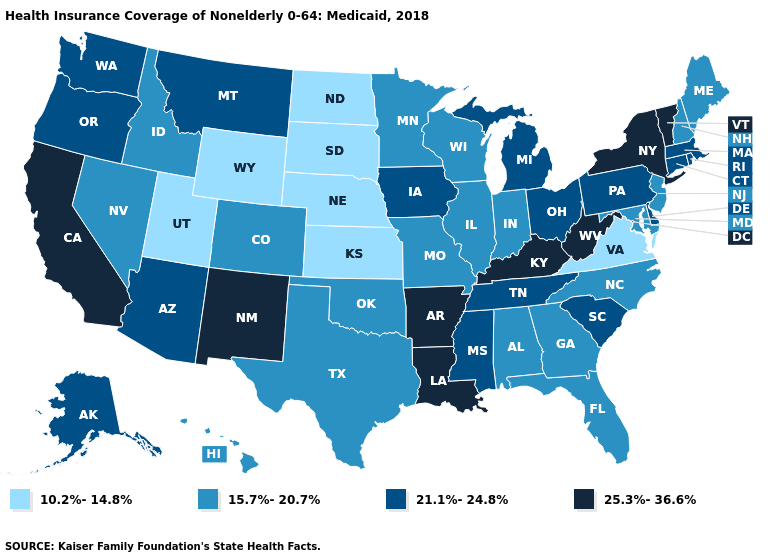Does Minnesota have a higher value than Texas?
Quick response, please. No. How many symbols are there in the legend?
Concise answer only. 4. Among the states that border Washington , which have the highest value?
Quick response, please. Oregon. Does Iowa have a higher value than Oregon?
Write a very short answer. No. What is the value of Alaska?
Answer briefly. 21.1%-24.8%. Which states have the lowest value in the Northeast?
Be succinct. Maine, New Hampshire, New Jersey. Among the states that border Texas , which have the lowest value?
Be succinct. Oklahoma. Name the states that have a value in the range 15.7%-20.7%?
Answer briefly. Alabama, Colorado, Florida, Georgia, Hawaii, Idaho, Illinois, Indiana, Maine, Maryland, Minnesota, Missouri, Nevada, New Hampshire, New Jersey, North Carolina, Oklahoma, Texas, Wisconsin. Does the map have missing data?
Be succinct. No. Name the states that have a value in the range 10.2%-14.8%?
Answer briefly. Kansas, Nebraska, North Dakota, South Dakota, Utah, Virginia, Wyoming. Does West Virginia have the highest value in the USA?
Give a very brief answer. Yes. Does Iowa have the highest value in the MidWest?
Quick response, please. Yes. Which states have the lowest value in the USA?
Be succinct. Kansas, Nebraska, North Dakota, South Dakota, Utah, Virginia, Wyoming. Name the states that have a value in the range 21.1%-24.8%?
Give a very brief answer. Alaska, Arizona, Connecticut, Delaware, Iowa, Massachusetts, Michigan, Mississippi, Montana, Ohio, Oregon, Pennsylvania, Rhode Island, South Carolina, Tennessee, Washington. Name the states that have a value in the range 15.7%-20.7%?
Short answer required. Alabama, Colorado, Florida, Georgia, Hawaii, Idaho, Illinois, Indiana, Maine, Maryland, Minnesota, Missouri, Nevada, New Hampshire, New Jersey, North Carolina, Oklahoma, Texas, Wisconsin. 